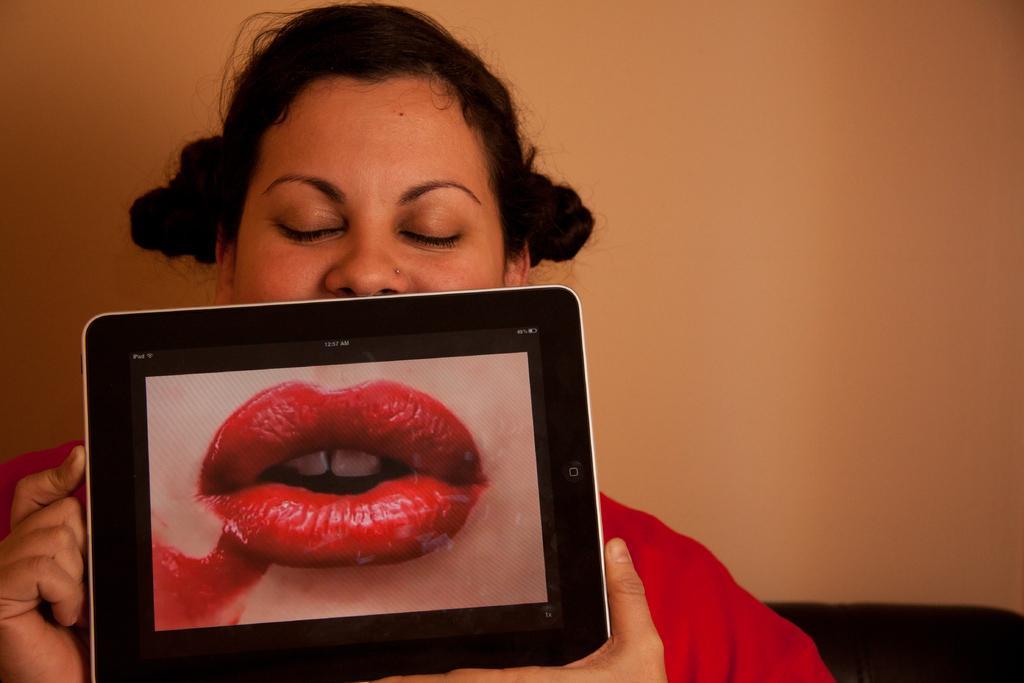Please provide a concise description of this image. In this image there is a girl in the middle who is holding the tablet. In the tablet there is a image of lips. In the background there is a wall. 